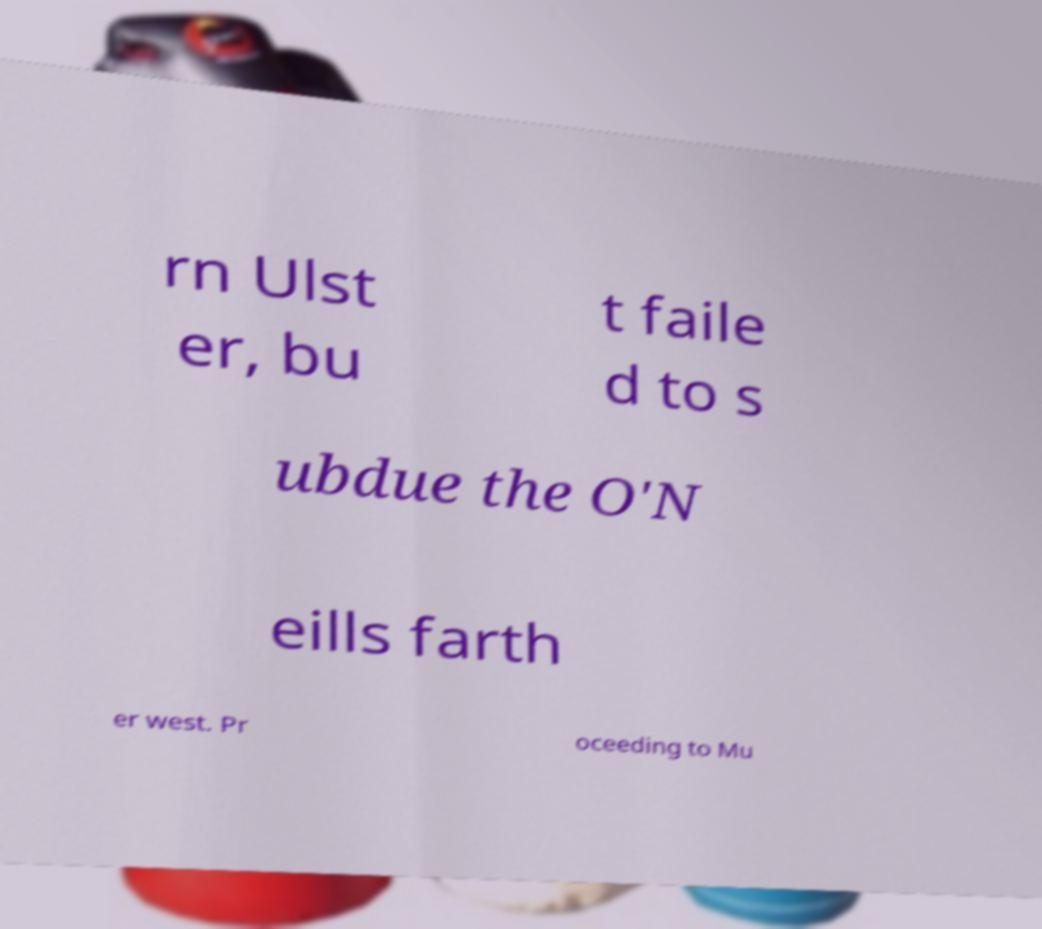For documentation purposes, I need the text within this image transcribed. Could you provide that? rn Ulst er, bu t faile d to s ubdue the O'N eills farth er west. Pr oceeding to Mu 